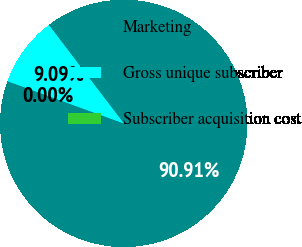<chart> <loc_0><loc_0><loc_500><loc_500><pie_chart><fcel>Marketing<fcel>Gross unique subscriber<fcel>Subscriber acquisition cost<nl><fcel>90.9%<fcel>9.09%<fcel>0.0%<nl></chart> 